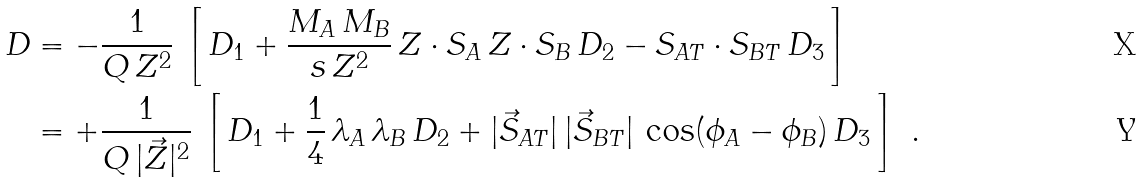<formula> <loc_0><loc_0><loc_500><loc_500>D & = - \frac { 1 } { Q \, Z ^ { 2 } } \, \left [ \, D _ { 1 } + \frac { M _ { A } \, M _ { B } } { s \, Z ^ { 2 } } \, Z \cdot S _ { A } \, Z \cdot S _ { B } \, D _ { 2 } - S _ { A T } \cdot S _ { B T } \, D _ { 3 } \, \right ] \\ & = + \frac { 1 } { Q \, | \vec { Z } | ^ { 2 } } \, \left [ \, D _ { 1 } + \frac { 1 } { 4 } \, \lambda _ { A } \, \lambda _ { B } \, D _ { 2 } + | \vec { S } _ { A T } | \, | \vec { S } _ { B T } | \, \cos ( \phi _ { A } - \phi _ { B } ) \, D _ { 3 } \, \right ] \ .</formula> 